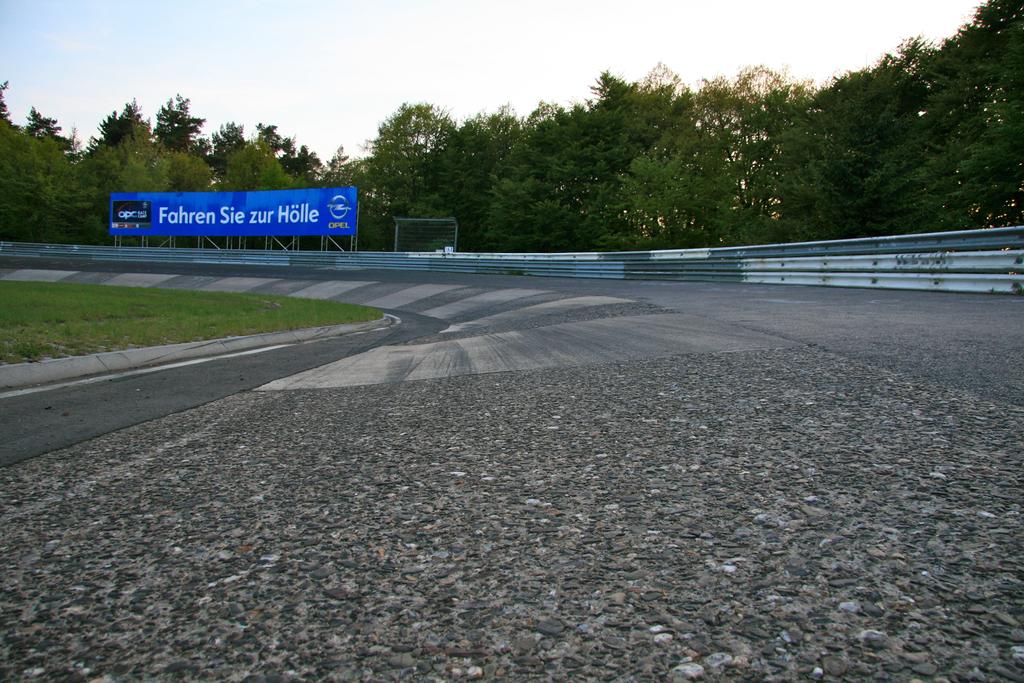What is on the blue sign?
Keep it short and to the point. Fahren sie zur holle. What sponsor is written on the blue banner in yellow writing?
Your answer should be very brief. Opel. 